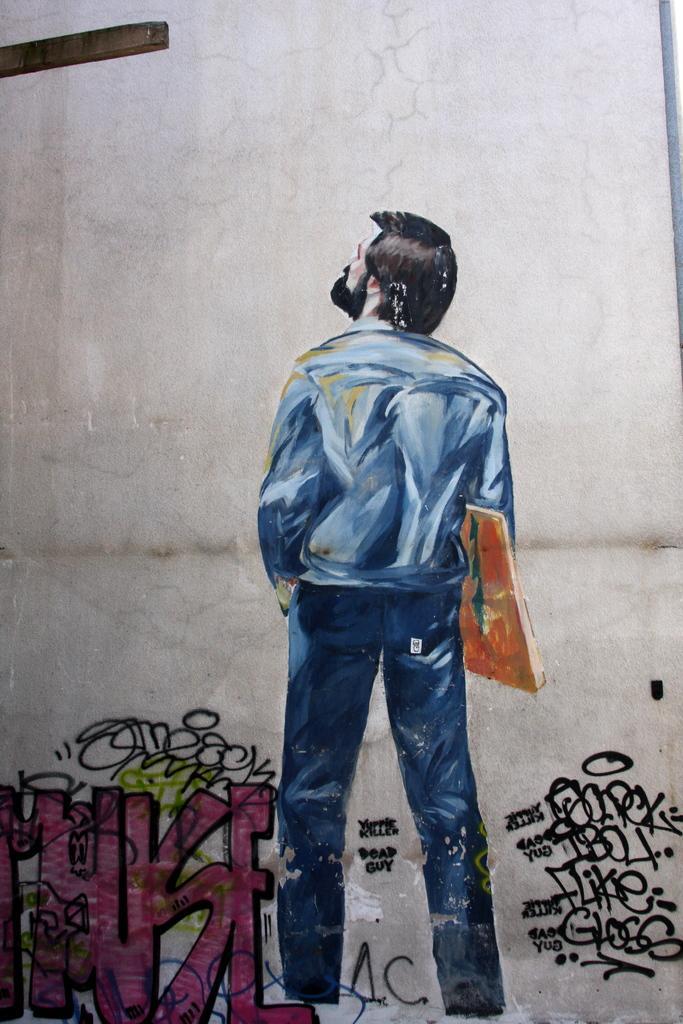Can you describe this image briefly? In this image I can see it's a painting a man is looking at that side. He wore shirt, trouser and holding a book in his hand and there is the text on the left side in pink color. 